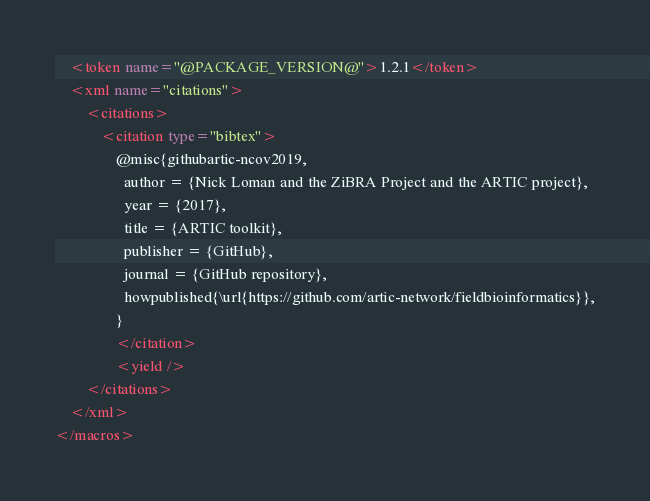Convert code to text. <code><loc_0><loc_0><loc_500><loc_500><_XML_>    <token name="@PACKAGE_VERSION@">1.2.1</token>
    <xml name="citations">
        <citations>
            <citation type="bibtex">
                @misc{githubartic-ncov2019,
                  author = {Nick Loman and the ZiBRA Project and the ARTIC project},
                  year = {2017},
                  title = {ARTIC toolkit},
                  publisher = {GitHub},
                  journal = {GitHub repository},
                  howpublished{\url{https://github.com/artic-network/fieldbioinformatics}},
                }
                </citation>
                <yield />
        </citations>
    </xml>
</macros>
</code> 